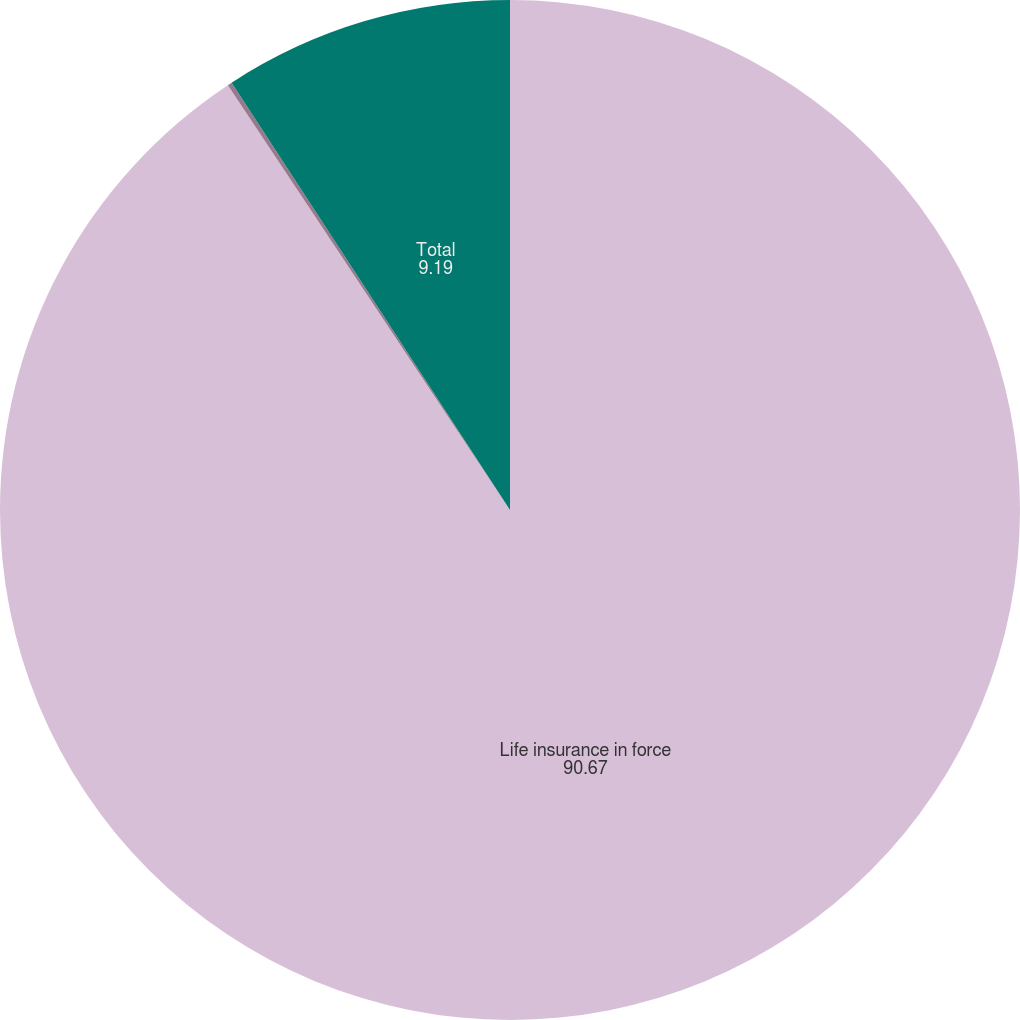Convert chart. <chart><loc_0><loc_0><loc_500><loc_500><pie_chart><fcel>Life insurance in force<fcel>Life insurance<fcel>Total<nl><fcel>90.67%<fcel>0.14%<fcel>9.19%<nl></chart> 